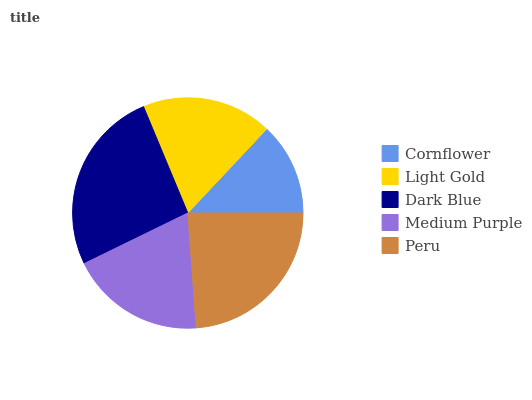Is Cornflower the minimum?
Answer yes or no. Yes. Is Dark Blue the maximum?
Answer yes or no. Yes. Is Light Gold the minimum?
Answer yes or no. No. Is Light Gold the maximum?
Answer yes or no. No. Is Light Gold greater than Cornflower?
Answer yes or no. Yes. Is Cornflower less than Light Gold?
Answer yes or no. Yes. Is Cornflower greater than Light Gold?
Answer yes or no. No. Is Light Gold less than Cornflower?
Answer yes or no. No. Is Medium Purple the high median?
Answer yes or no. Yes. Is Medium Purple the low median?
Answer yes or no. Yes. Is Dark Blue the high median?
Answer yes or no. No. Is Peru the low median?
Answer yes or no. No. 